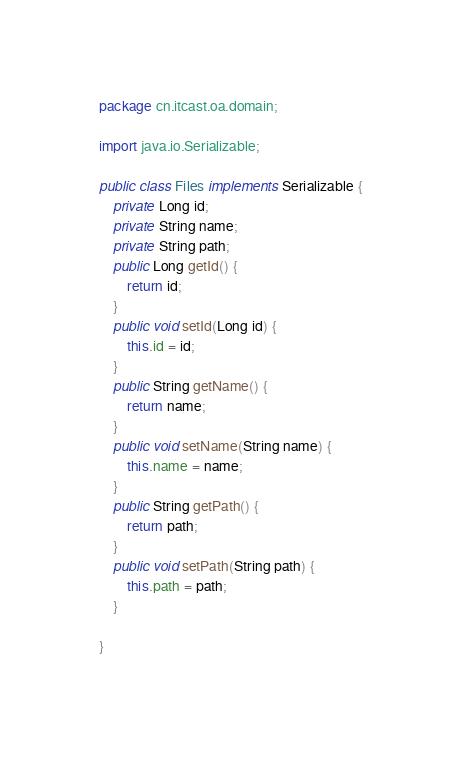Convert code to text. <code><loc_0><loc_0><loc_500><loc_500><_Java_>package cn.itcast.oa.domain;

import java.io.Serializable;

public class Files implements Serializable {
	private Long id;
	private String name;
	private String path;
	public Long getId() {
		return id;
	}
	public void setId(Long id) {
		this.id = id;
	}
	public String getName() {
		return name;
	}
	public void setName(String name) {
		this.name = name;
	}
	public String getPath() {
		return path;
	}
	public void setPath(String path) {
		this.path = path;
	}
	
}
</code> 